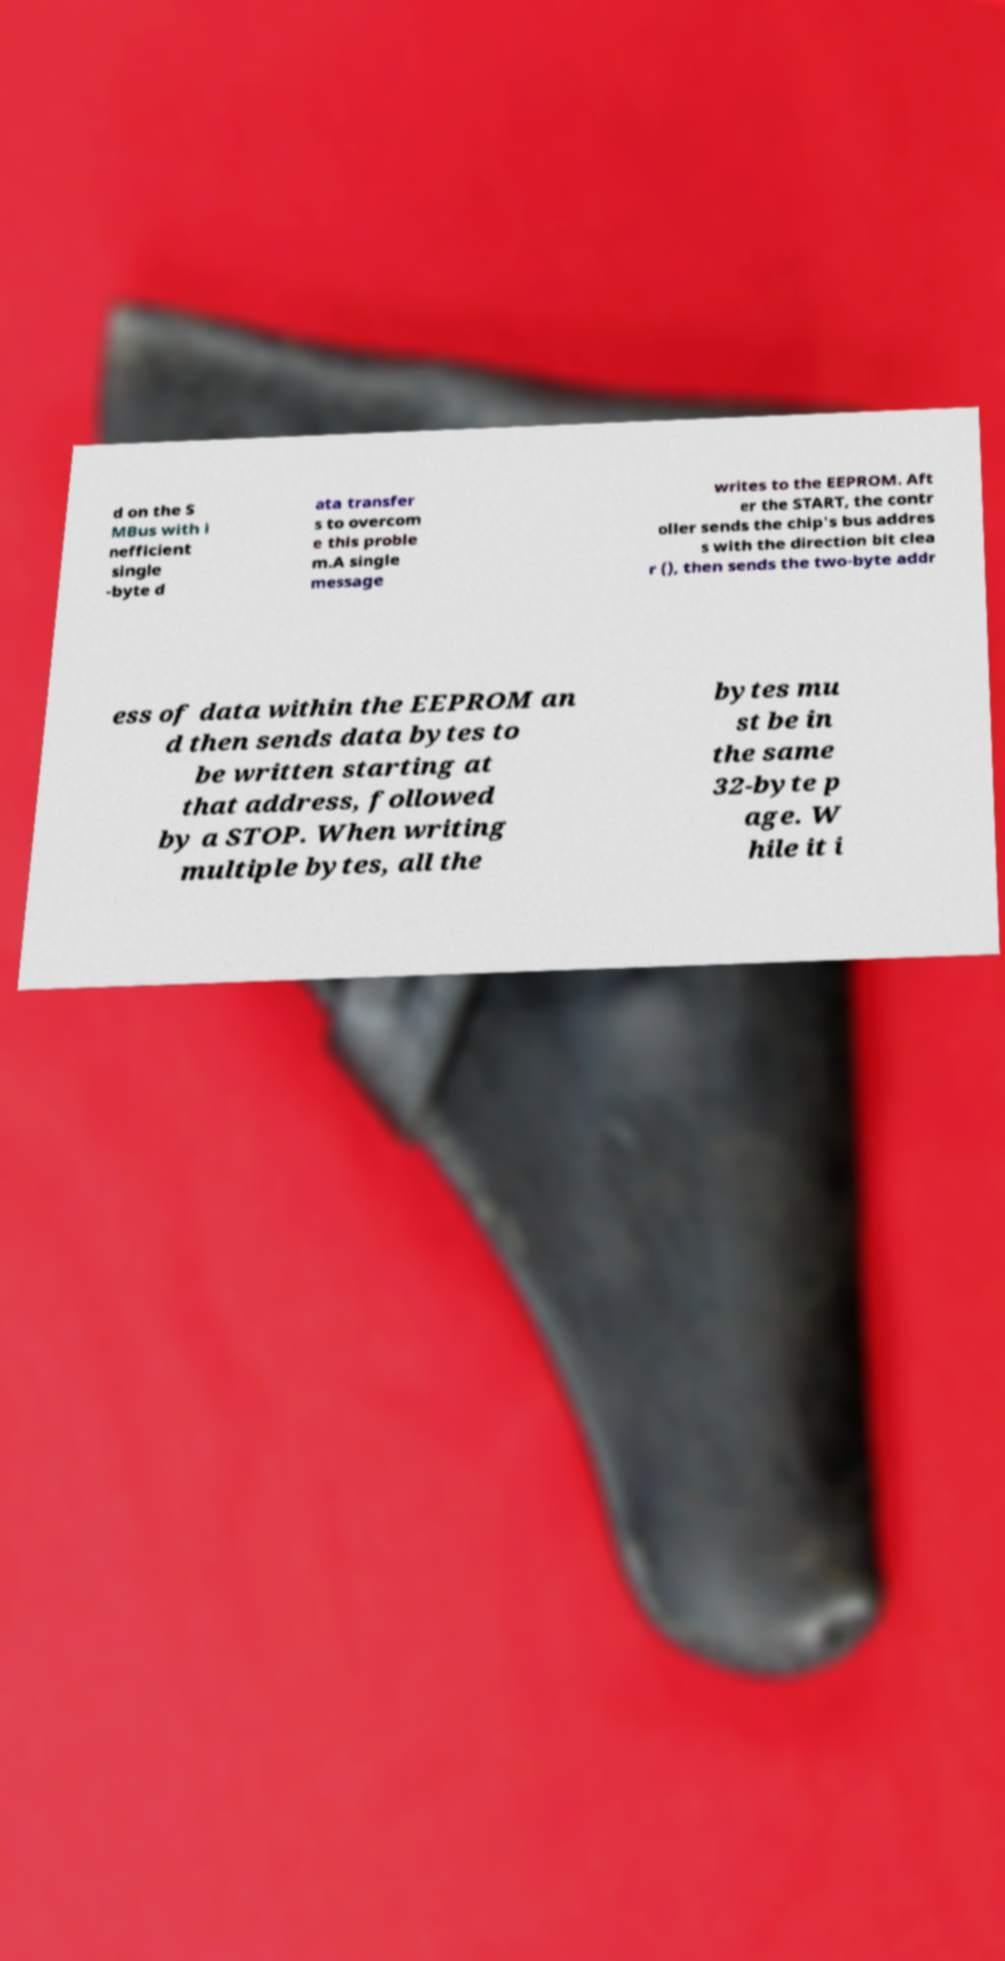Can you read and provide the text displayed in the image?This photo seems to have some interesting text. Can you extract and type it out for me? d on the S MBus with i nefficient single -byte d ata transfer s to overcom e this proble m.A single message writes to the EEPROM. Aft er the START, the contr oller sends the chip's bus addres s with the direction bit clea r (), then sends the two-byte addr ess of data within the EEPROM an d then sends data bytes to be written starting at that address, followed by a STOP. When writing multiple bytes, all the bytes mu st be in the same 32-byte p age. W hile it i 